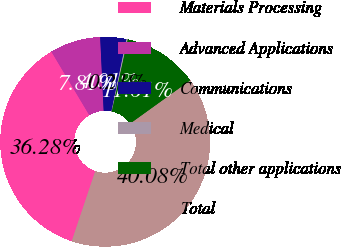Convert chart to OTSL. <chart><loc_0><loc_0><loc_500><loc_500><pie_chart><fcel>Materials Processing<fcel>Advanced Applications<fcel>Communications<fcel>Medical<fcel>Total other applications<fcel>Total<nl><fcel>36.28%<fcel>7.81%<fcel>4.01%<fcel>0.21%<fcel>11.61%<fcel>40.08%<nl></chart> 